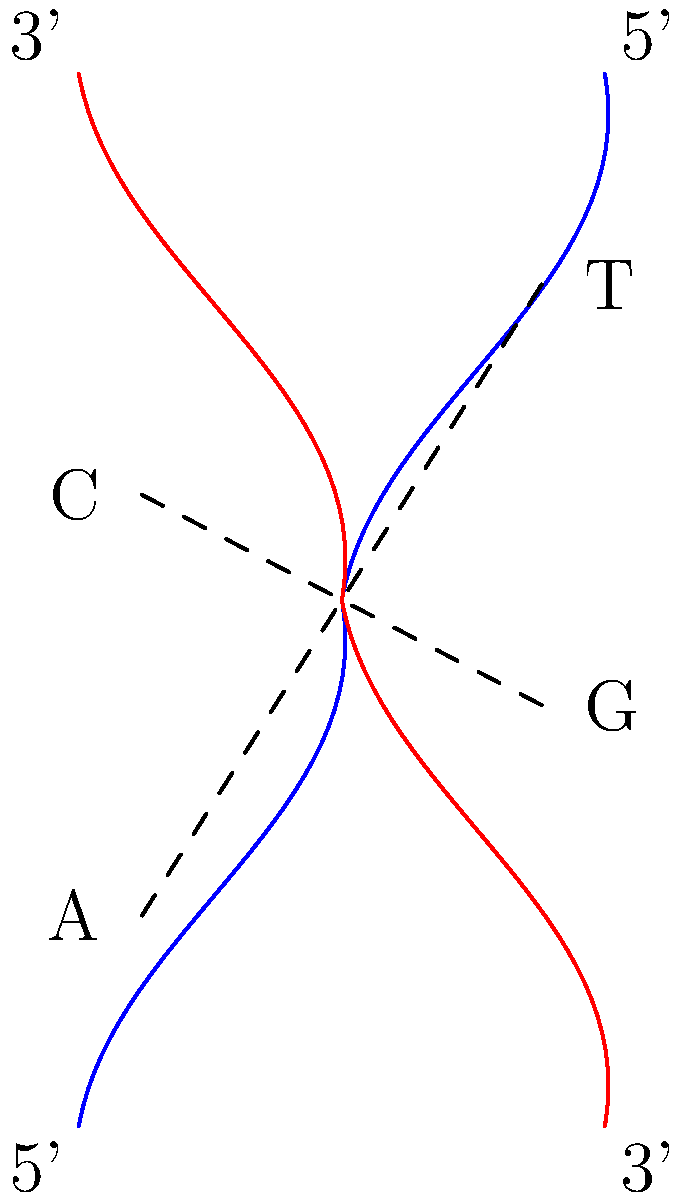In the simplified DNA double helix diagram, which base pair is represented by the lower dashed line, and what is the directionality of the blue strand? To answer this question, let's analyze the diagram step-by-step:

1. The diagram shows a simplified DNA double helix with two strands: one in blue and one in red.

2. There are two dashed lines representing base pairs connecting the strands.

3. The lower dashed line connects a "C" on the left (blue strand) with a "G" on the right (red strand).

4. This represents the base pairing between Cytosine (C) and Guanine (G), which is one of the complementary base pairs in DNA.

5. For the directionality of the blue strand:
   - The 5' end is labeled at the bottom of the blue strand.
   - The 3' end is labeled at the top of the blue strand.

6. In DNA, the convention is to read the sequence from the 5' end to the 3' end.

Therefore, the base pair represented by the lower dashed line is C-G, and the blue strand runs in the 5' to 3' direction from bottom to top.
Answer: C-G base pair; 5' to 3' (bottom to top) 